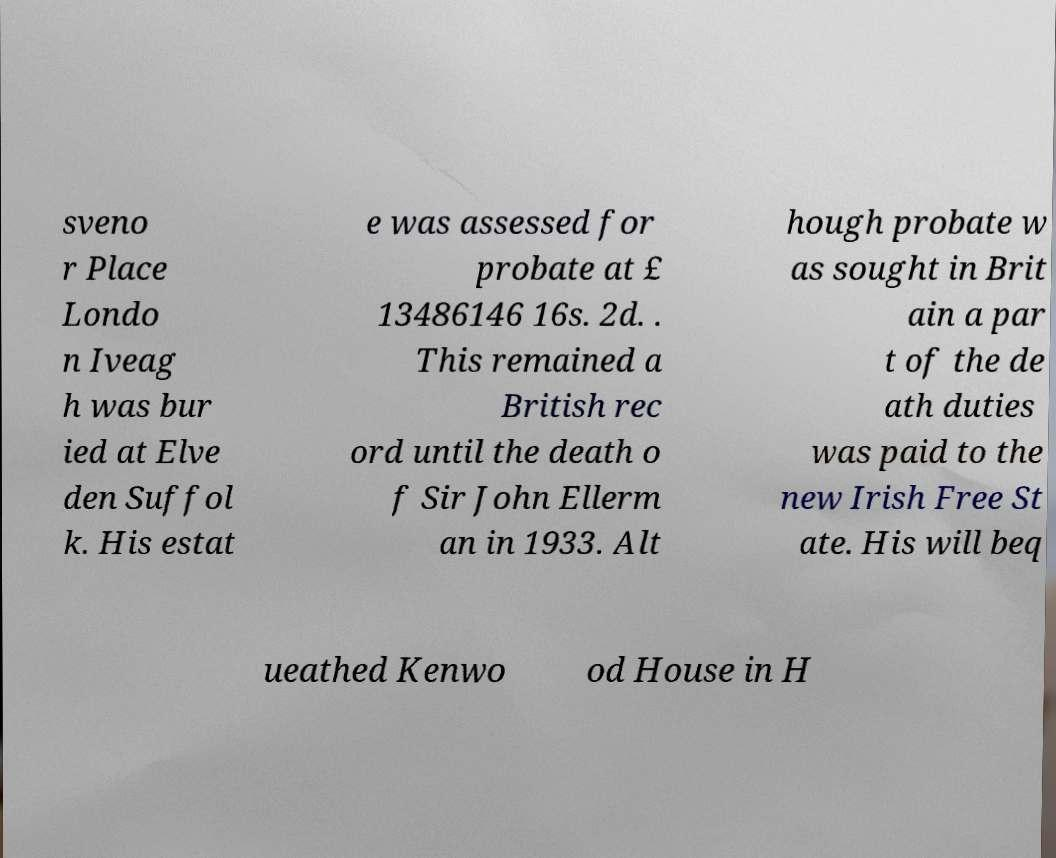For documentation purposes, I need the text within this image transcribed. Could you provide that? sveno r Place Londo n Iveag h was bur ied at Elve den Suffol k. His estat e was assessed for probate at £ 13486146 16s. 2d. . This remained a British rec ord until the death o f Sir John Ellerm an in 1933. Alt hough probate w as sought in Brit ain a par t of the de ath duties was paid to the new Irish Free St ate. His will beq ueathed Kenwo od House in H 